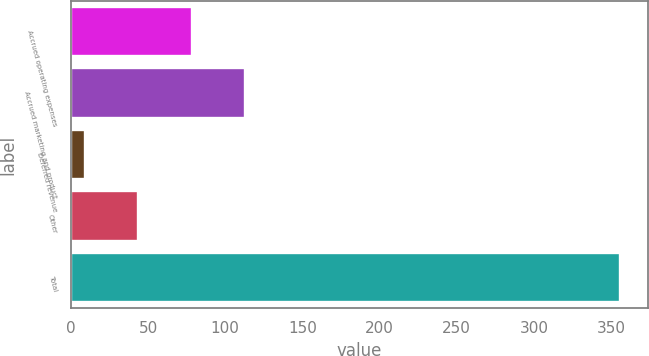Convert chart. <chart><loc_0><loc_0><loc_500><loc_500><bar_chart><fcel>Accrued operating expenses<fcel>Accrued marketing and product<fcel>Deferred revenue<fcel>Other<fcel>Total<nl><fcel>78.4<fcel>113.1<fcel>9<fcel>43.7<fcel>356<nl></chart> 